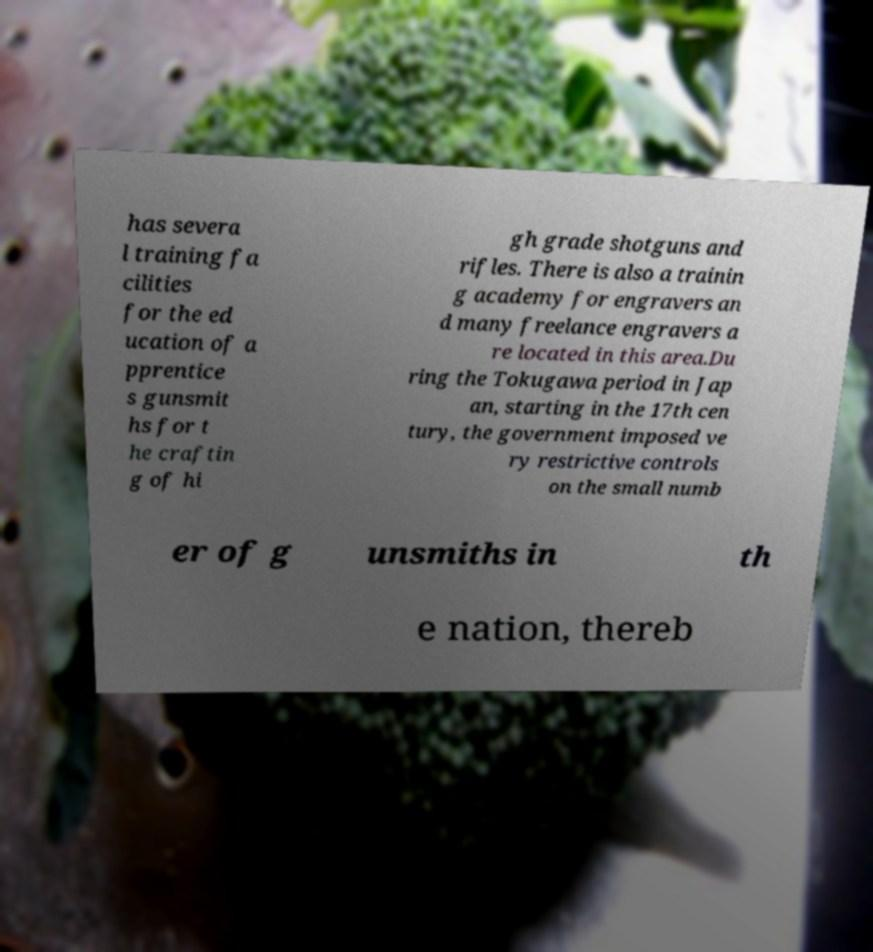For documentation purposes, I need the text within this image transcribed. Could you provide that? has severa l training fa cilities for the ed ucation of a pprentice s gunsmit hs for t he craftin g of hi gh grade shotguns and rifles. There is also a trainin g academy for engravers an d many freelance engravers a re located in this area.Du ring the Tokugawa period in Jap an, starting in the 17th cen tury, the government imposed ve ry restrictive controls on the small numb er of g unsmiths in th e nation, thereb 